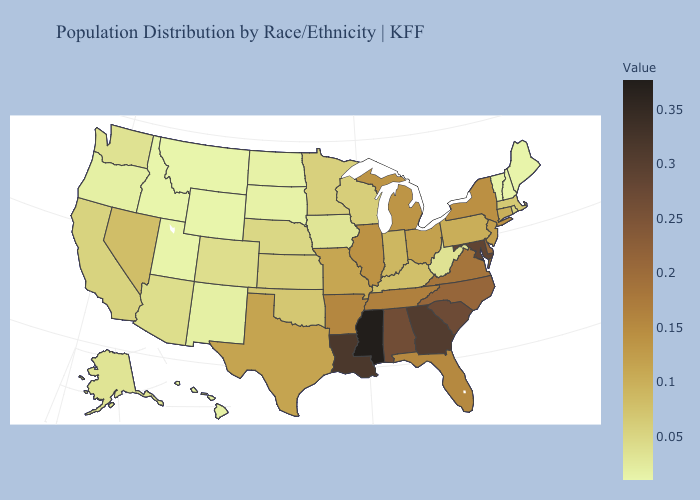Does Wyoming have the lowest value in the USA?
Quick response, please. Yes. Does Pennsylvania have the highest value in the Northeast?
Short answer required. No. Which states have the lowest value in the USA?
Write a very short answer. Idaho, Montana, Wyoming. 